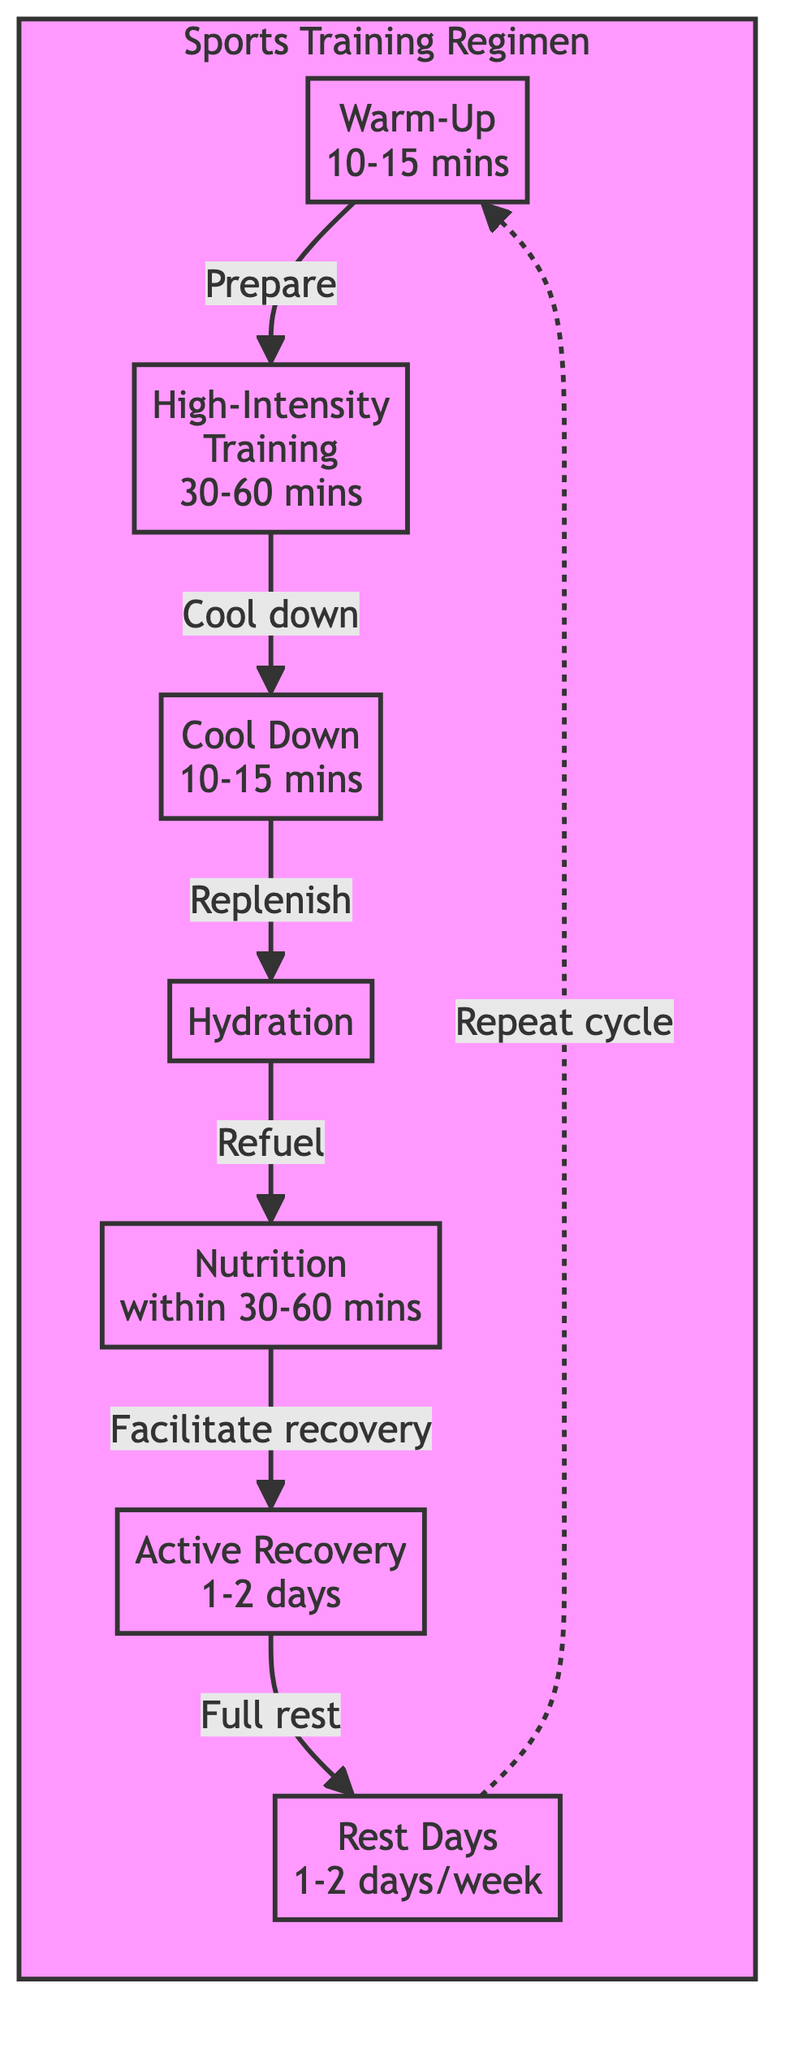What is the duration of the Warm-Up? The diagram indicates that the duration for the Warm-Up is 10-15 minutes. This information is directly stated in the node representing the Warm-Up.
Answer: 10-15 minutes What comes after High-Intensity Training? In the flow of the diagram, after High-Intensity Training, the next phase is Cool Down. This is shown as an arrow leading from High-Intensity Training to Cool Down.
Answer: Cool Down How long should Active Recovery last? The node for Active Recovery specifies that it should last for 1-2 days post-training, providing direct guidance on the duration of this recovery phase.
Answer: 1-2 days How many rest days are recommended per week? The diagram states that 1-2 Rest Days are recommended per week to allow for muscle recovery and to avoid overtraining. This is directly noted in the Rest Days node.
Answer: 1-2 days What is the purpose of Hydration in the training regimen? The Hydration node outlines that its purpose is to replenish fluids lost during training, which is essential in the overall training and recovery process.
Answer: Replenishing fluids What should you consume within 30-60 minutes post-training? According to the Nutrition node, it is advised to consume a post-training meal focused on protein and carbohydrates within 30-60 minutes. This guidance directly corresponds to nutritional needs after a workout.
Answer: A post-training meal Which activity precedes Rest Days in the cycle? The flow of the diagram indicates that Active Recovery directly precedes Rest Days, as shown by the arrow connecting these two nodes. Therefore, engaging in Active Recovery is necessary before entering the rest period.
Answer: Active Recovery What activity follows Cool Down in the training regimen? Following Cool Down, the next activity in the diagram is Hydration. This can be seen from the directional flow connecting Cool Down to Hydration, indicating the sequence in the regimen.
Answer: Hydration 